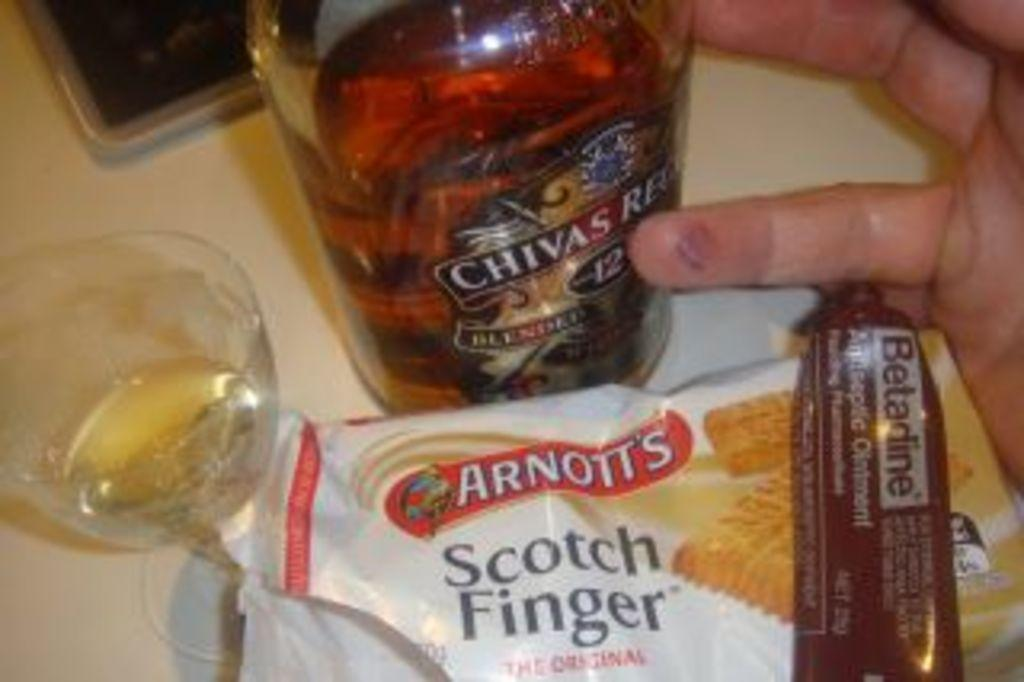<image>
Describe the image concisely. Bottle of Chivas Regal next to a pack of Arnott's Scotch Fingers. 